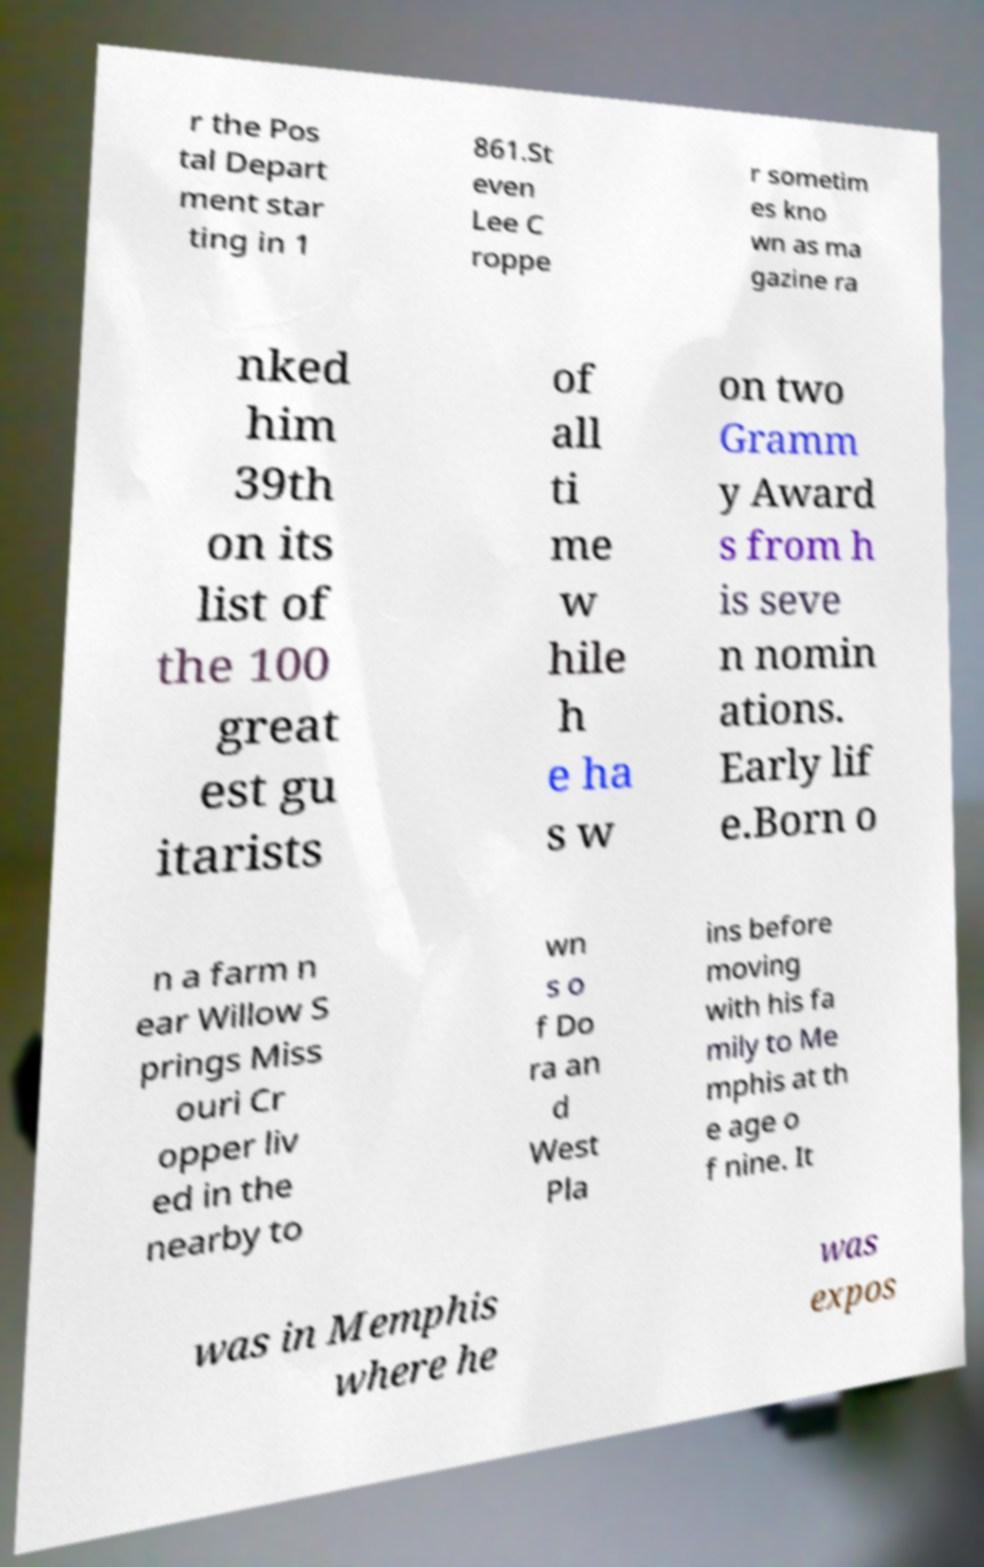I need the written content from this picture converted into text. Can you do that? r the Pos tal Depart ment star ting in 1 861.St even Lee C roppe r sometim es kno wn as ma gazine ra nked him 39th on its list of the 100 great est gu itarists of all ti me w hile h e ha s w on two Gramm y Award s from h is seve n nomin ations. Early lif e.Born o n a farm n ear Willow S prings Miss ouri Cr opper liv ed in the nearby to wn s o f Do ra an d West Pla ins before moving with his fa mily to Me mphis at th e age o f nine. It was in Memphis where he was expos 